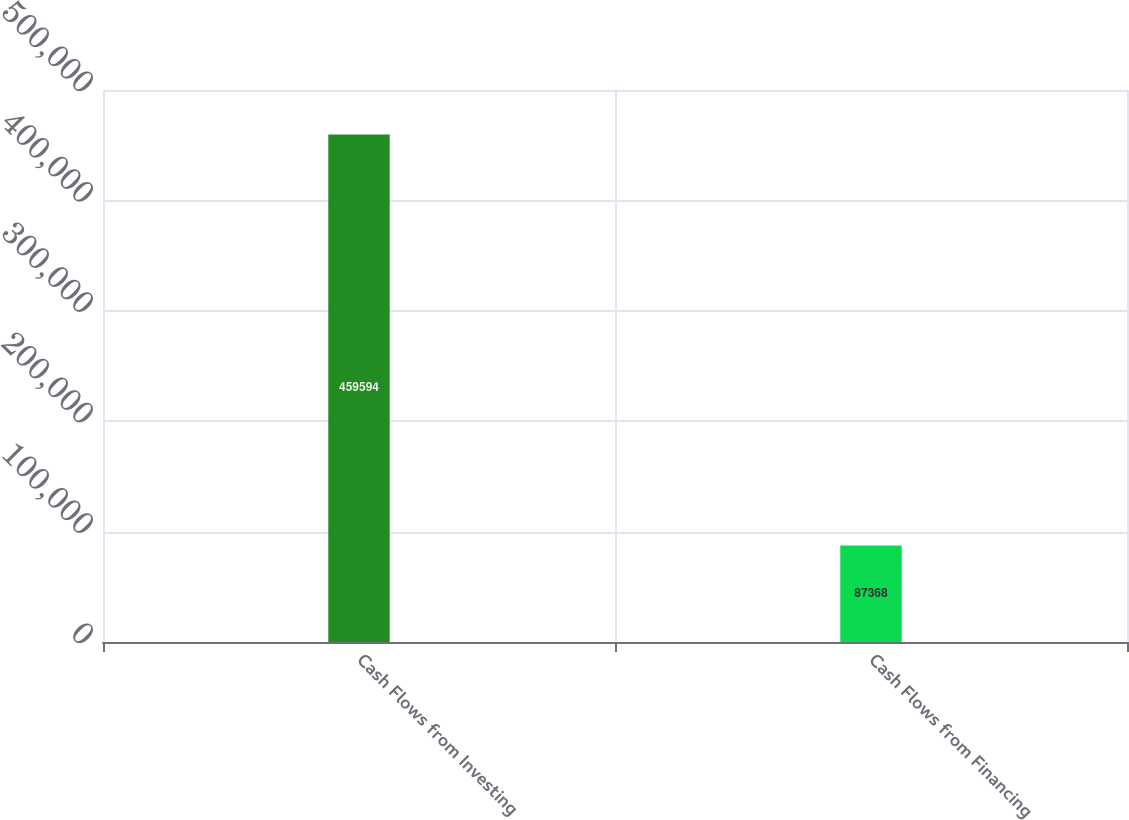Convert chart to OTSL. <chart><loc_0><loc_0><loc_500><loc_500><bar_chart><fcel>Cash Flows from Investing<fcel>Cash Flows from Financing<nl><fcel>459594<fcel>87368<nl></chart> 